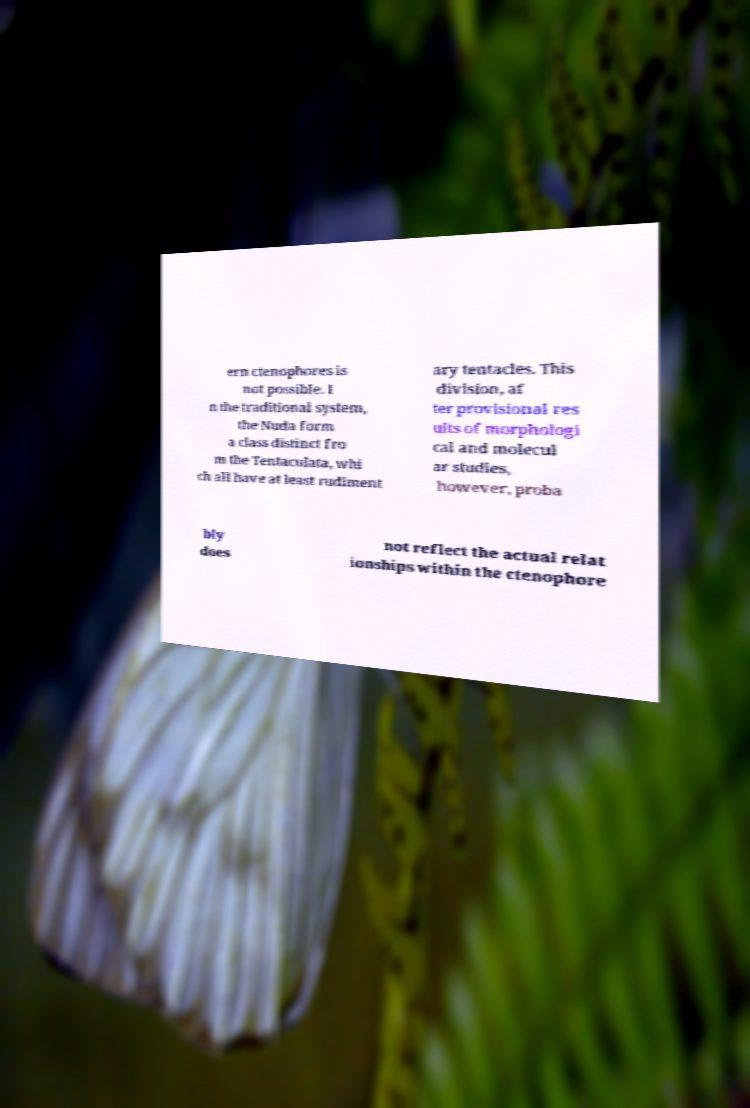Please read and relay the text visible in this image. What does it say? ern ctenophores is not possible. I n the traditional system, the Nuda form a class distinct fro m the Tentaculata, whi ch all have at least rudiment ary tentacles. This division, af ter provisional res ults of morphologi cal and molecul ar studies, however, proba bly does not reflect the actual relat ionships within the ctenophore 